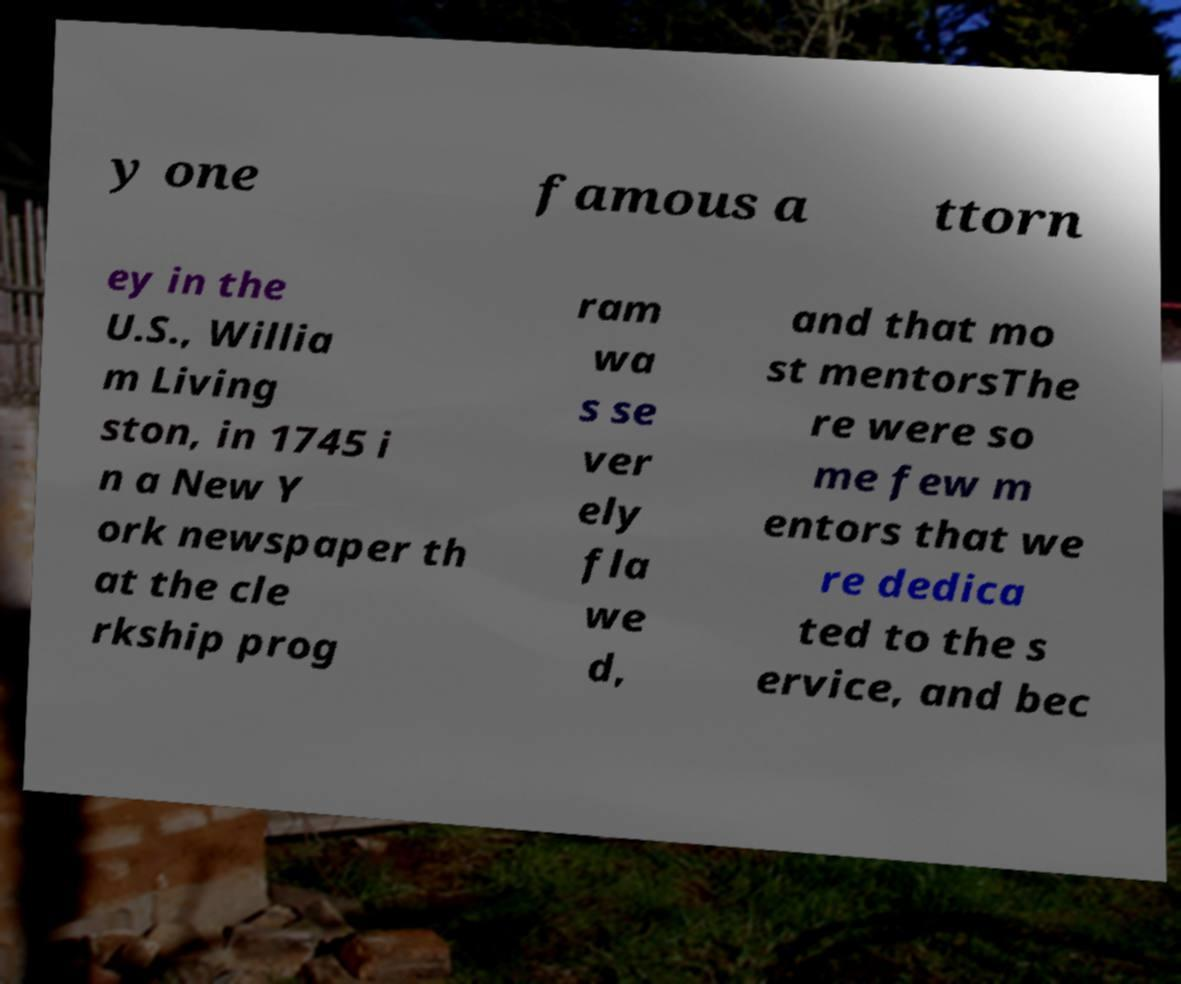Can you accurately transcribe the text from the provided image for me? y one famous a ttorn ey in the U.S., Willia m Living ston, in 1745 i n a New Y ork newspaper th at the cle rkship prog ram wa s se ver ely fla we d, and that mo st mentorsThe re were so me few m entors that we re dedica ted to the s ervice, and bec 